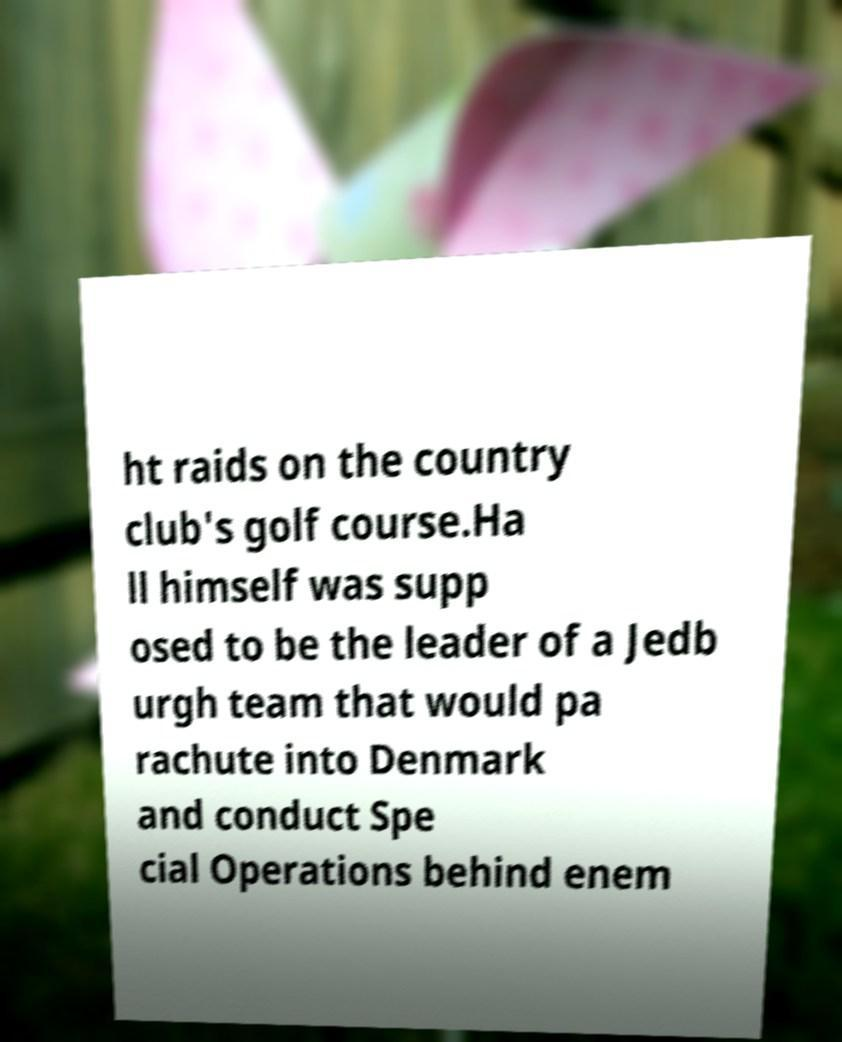For documentation purposes, I need the text within this image transcribed. Could you provide that? ht raids on the country club's golf course.Ha ll himself was supp osed to be the leader of a Jedb urgh team that would pa rachute into Denmark and conduct Spe cial Operations behind enem 